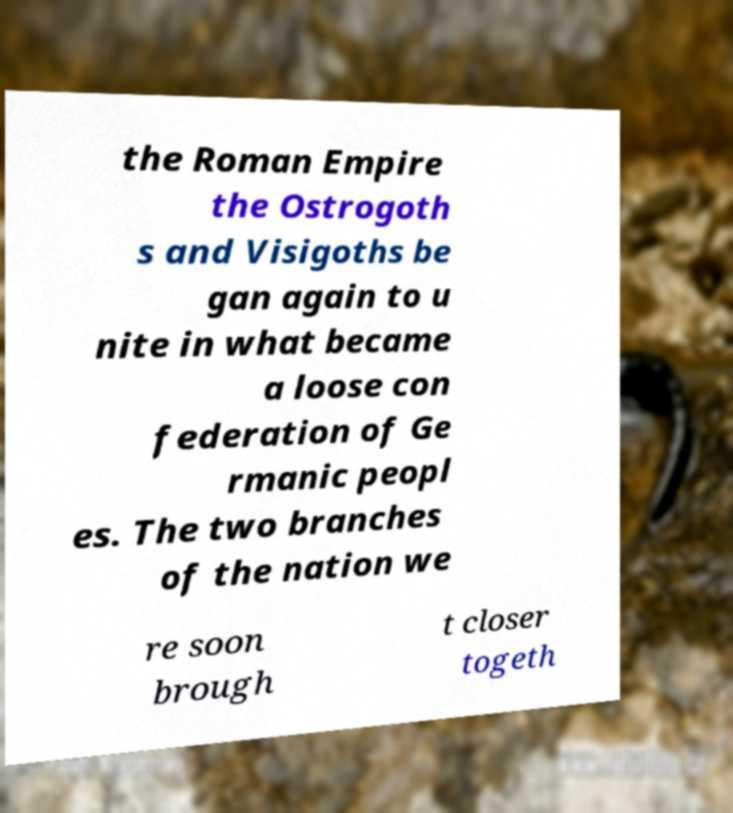Could you assist in decoding the text presented in this image and type it out clearly? the Roman Empire the Ostrogoth s and Visigoths be gan again to u nite in what became a loose con federation of Ge rmanic peopl es. The two branches of the nation we re soon brough t closer togeth 